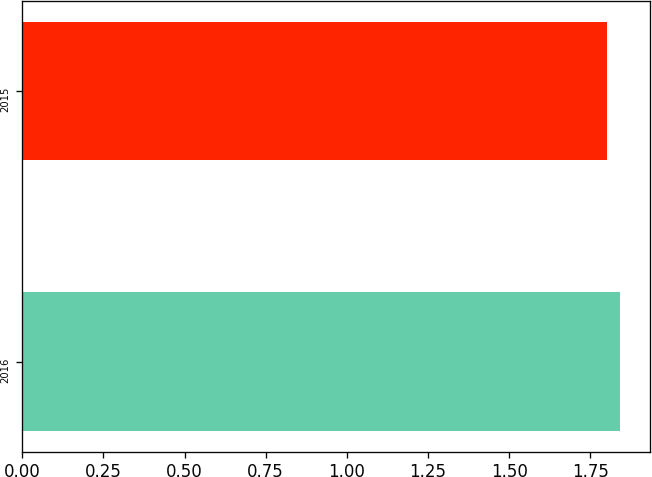Convert chart to OTSL. <chart><loc_0><loc_0><loc_500><loc_500><bar_chart><fcel>2016<fcel>2015<nl><fcel>1.84<fcel>1.8<nl></chart> 